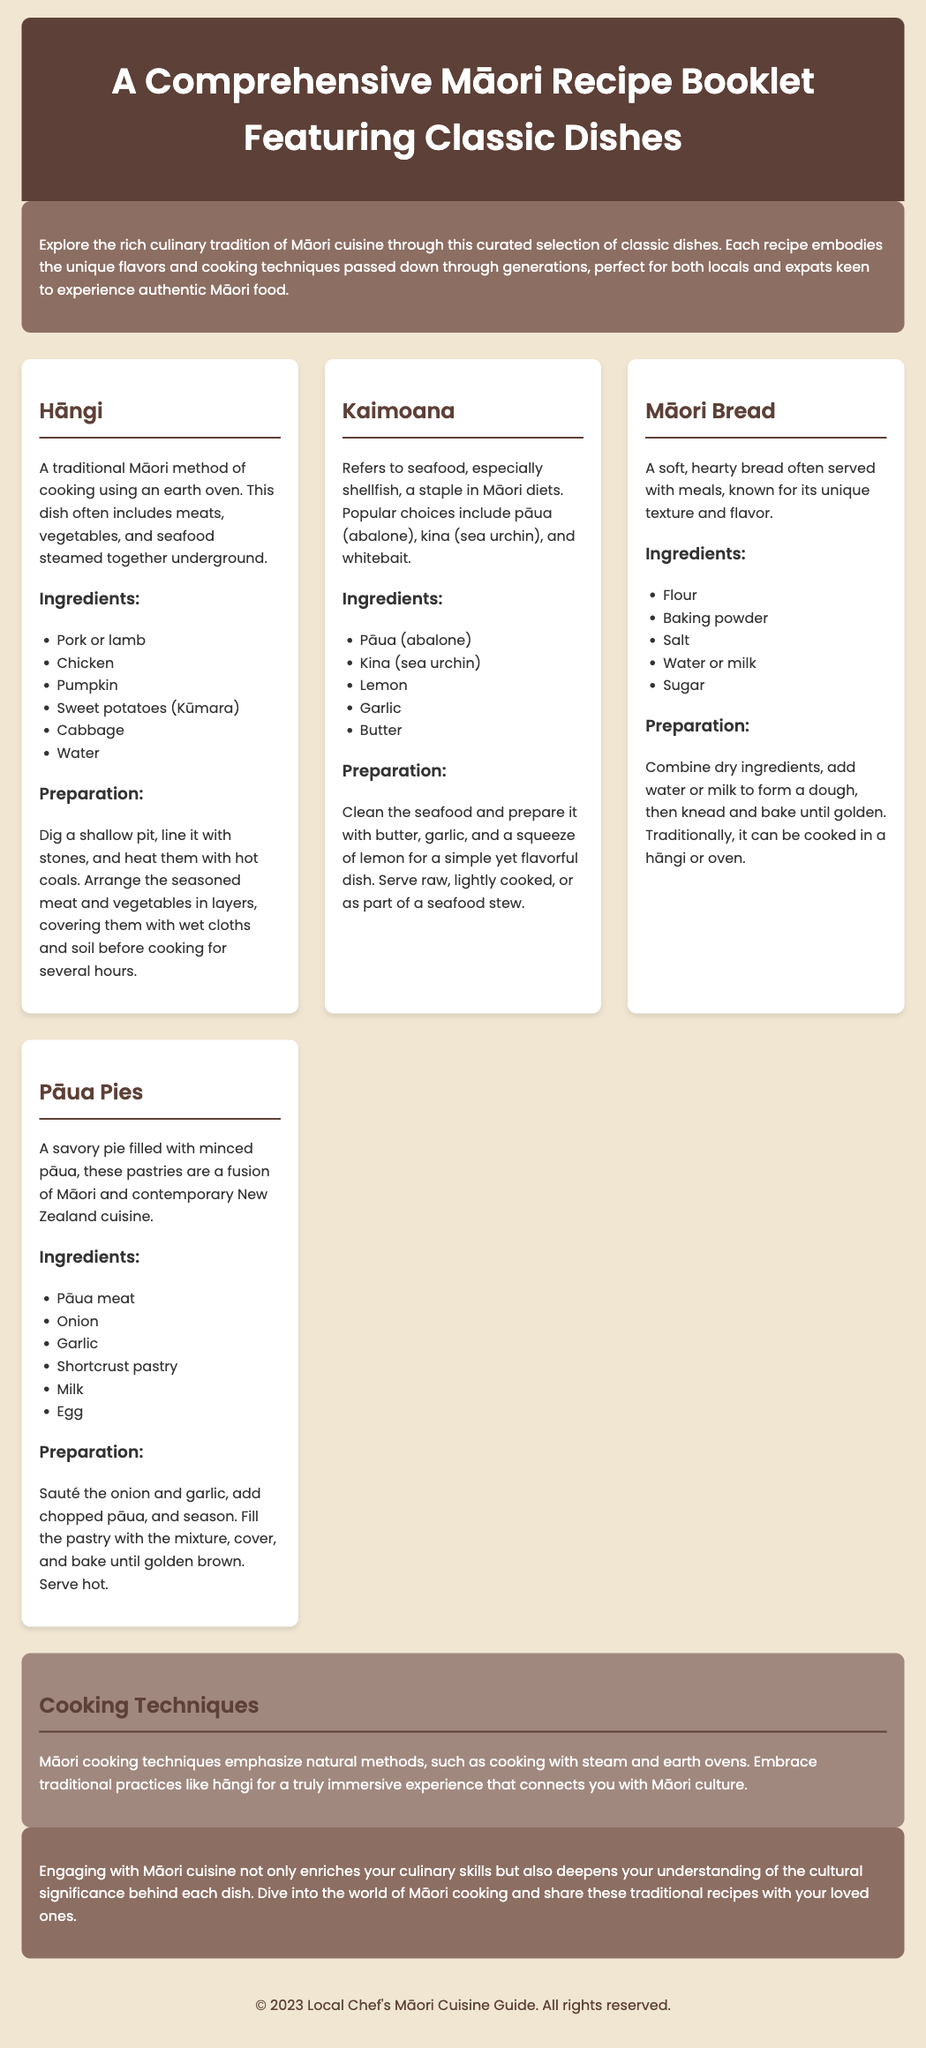What is the title of the document? The title is prominently displayed in the header section of the document, which outlines the content covered within it.
Answer: A Comprehensive Māori Recipe Booklet Featuring Classic Dishes How many recipes are listed in the document? The document contains a selection of traditional Māori recipes, with each recipe clearly separated within its own section.
Answer: Four What cooking method is used in Hāngi? The Hāngi recipe describes a traditional method of cooking that involves an underground technique, utilizing hot stones and soil.
Answer: Earth oven What is a key ingredient in Kaimoana? The Kaimoana recipe specifically mentions seafood as a central component along with other listed ingredients.
Answer: Pāua (abalone) What unique ingredient is used in Māori Bread? The Māori Bread recipe includes specific dry ingredients to create its distinctive texture and flavor.
Answer: Kūmara What is the main focus of the cooking techniques section? The cooking techniques section elaborates on traditional Māori methods emphasizing natural cooking practices.
Answer: Natural methods How does the document encourage understanding of Māori cuisine? The conclusion highlights the significance of cultural engagement through the recipes provided in the booklet.
Answer: Cultural significance What type of cuisine does the Pāua Pies recipe represent? The Pāua Pies recipe reflects a combination of traditional Māori and modern culinary influences.
Answer: Fusion What color scheme is used for the introductory section? The introductory section has a specific color scheme that enhances its visual appeal and theme throughout the document.
Answer: Background color #8d6e63 